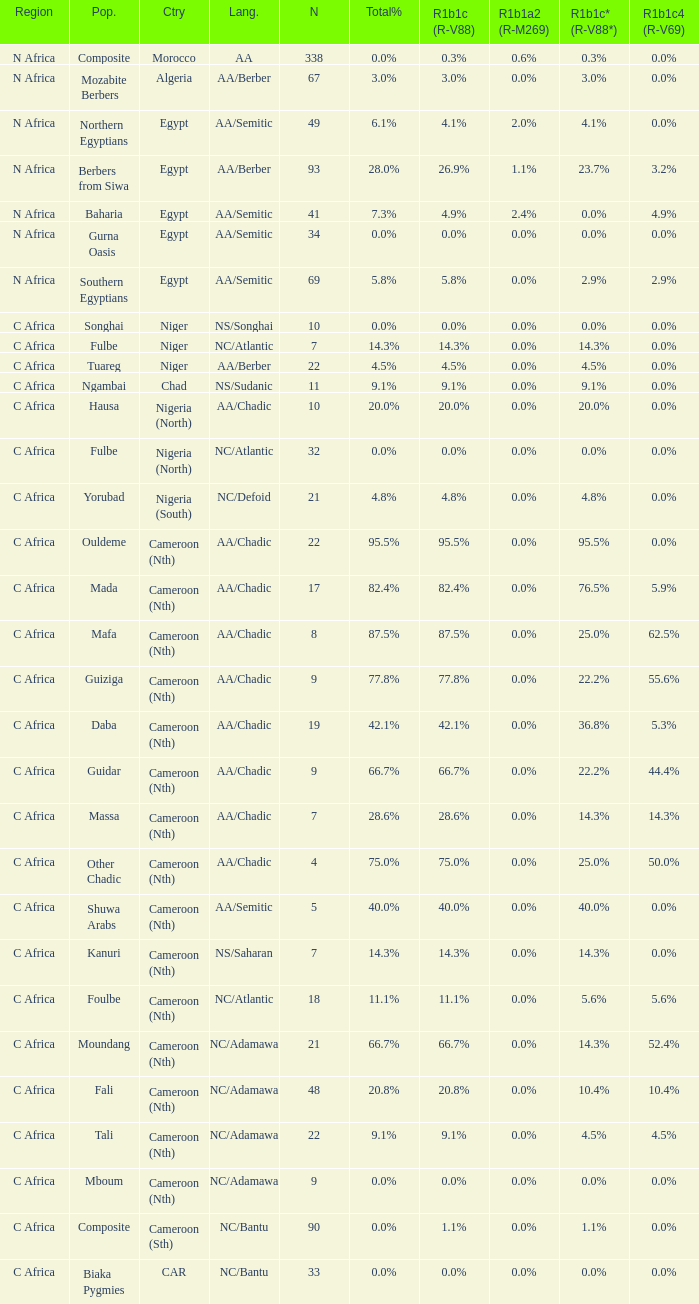How many n are listed for berbers from siwa? 1.0. 